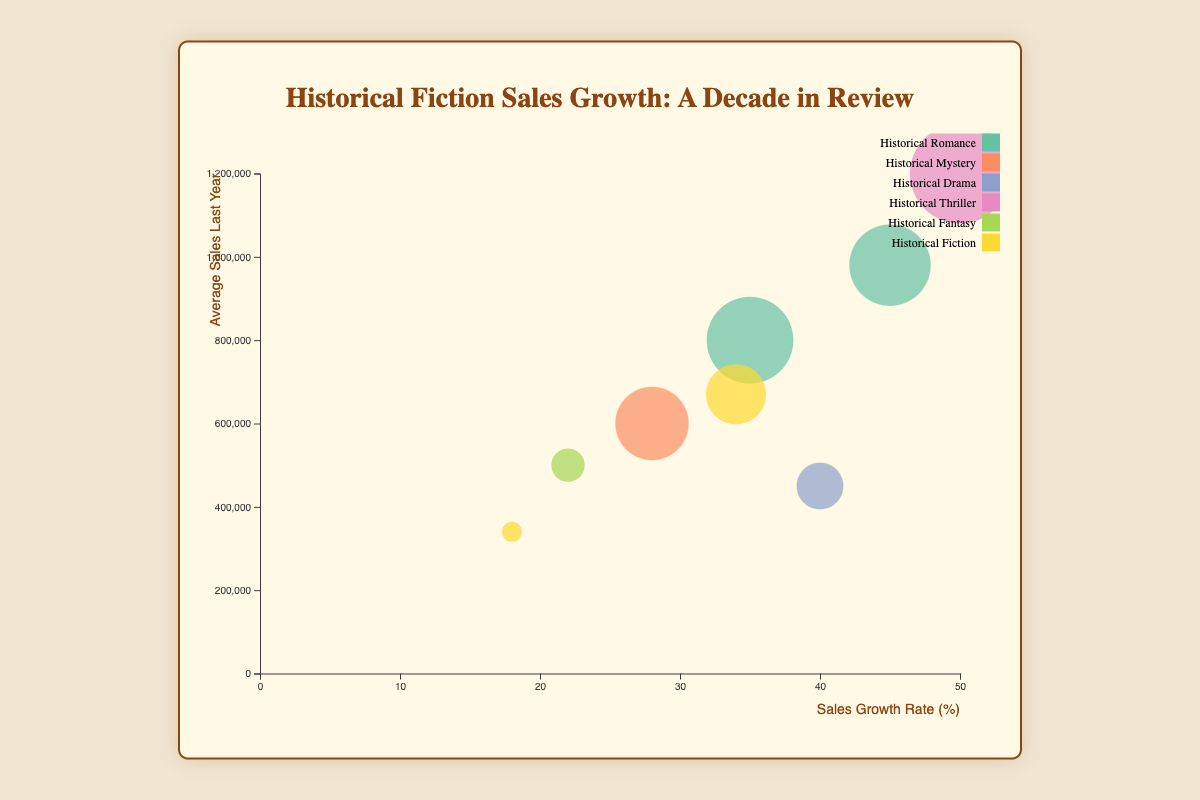Which genre experiences the highest sales growth rate? By looking at the x-axis, which represents the sales growth rate, we can identify that the bubble furthest to the right corresponds to the highest sales growth rate. This bubble is for the "Historical Thriller" genre authored by Ken Follett.
Answer: Historical Thriller What is the average sales last year for authors in North America? To find the average, we consider the data points for the "North America" region: Philippa Gregory (800,000) and Ken Follett (1,200,000). Adding these gives 2,000,000. Dividing by the number of authors (2), we get 1,000,000.
Answer: 1,000,000 Which author has the lowest popularity score and what is it? By examining the size of the bubbles, which represents the popularity score, we find the smallest bubble corresponds to the author from Africa, Chinua Achebe, with a popularity score of 65.
Answer: Chinua Achebe (65) Compare the average sales last year of Historical Romance in North America vs Europe. Which is higher? Philippa Gregory (North America) has 800,000 and Diana Gabaldon (Europe) has 980,000. Comparing these two values, 980,000 is higher.
Answer: Europe Which region has authors with the highest cumulative average sales last year? Adding average sales last year for each region: North America: (800,000 + 1,200,000) = 2,000,000, Europe: (600,000 + 500,000 + 980,000) = 2,080,000, Asia: (450,000), South America: (670,000), Africa: (340,000). Europe has the highest cumulative sales at 2,080,000.
Answer: Europe Between 'Historical Romance' and 'Historical Fiction,' which genre has a higher average sales growth rate in Europe? Calculate the average for each genre in Europe. Historical Romance: Diana Gabaldon (45%) alone. Historical Fiction: No authors. Since 'Historical Romance' has an author with 45% and 'Historical Fiction' has none, 'Historical Romance' is higher.
Answer: Historical Romance How many unique genres are represented in the data? We look at all the genre names and identify the unique ones: Historical Romance, Historical Mystery, Historical Drama, Historical Thriller, Historical Fantasy, Historical Fiction. Counting these, we get 6 unique genres.
Answer: 6 Which author has the highest popularity score, and what is the corresponding sales growth rate? By checking the biggest bubble (highest popularity score), we find Ken Follett with a popularity score of 95, and his sales growth rate is 50%.
Answer: Ken Follett (50%) Which author has the lowest sales growth rate? By looking at the bubbles closer to the left on the x-axis, the bubble for Chinua Achebe has the sales growth rate of 18%.
Answer: Chinua Achebe What is the combined popularity score of authors in Europe? Adding up the popularity scores for European authors: Bernard Cornwell (85), Guy Gavriel Kay (70), Diana Gabaldon (88). The sum is 85 + 70 + 88 = 243.
Answer: 243 